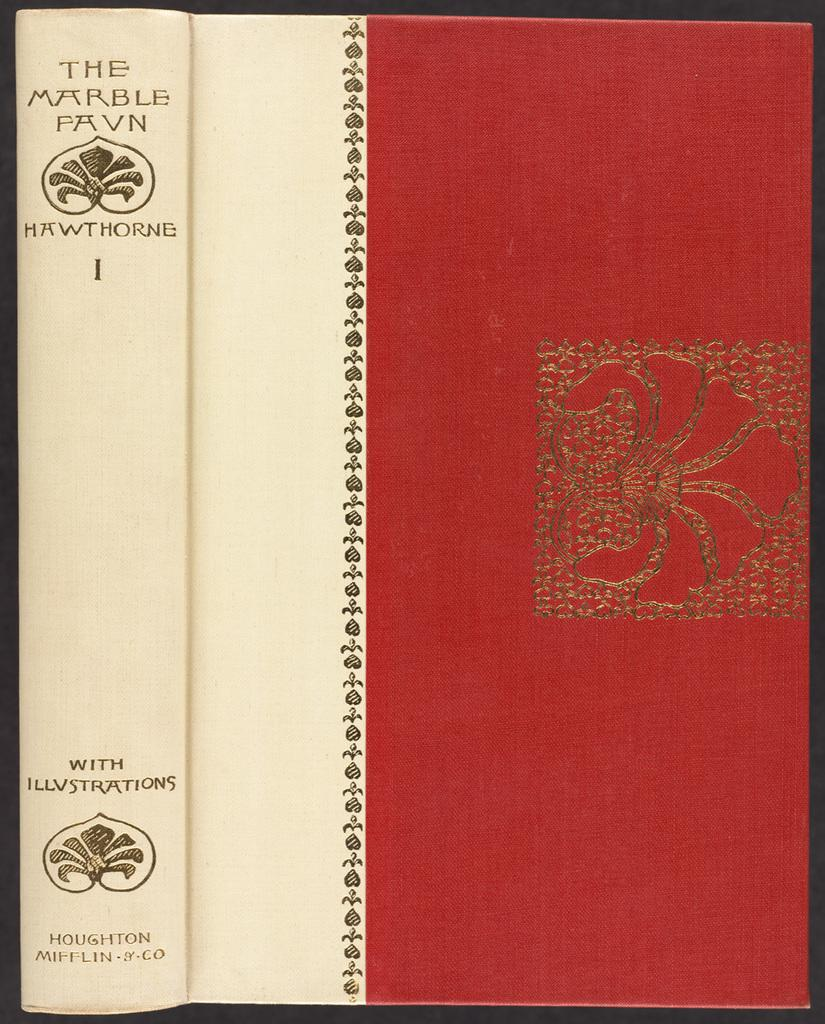Provide a one-sentence caption for the provided image. A red and white hardback book. On the spine it has text: "With Illustrations". 